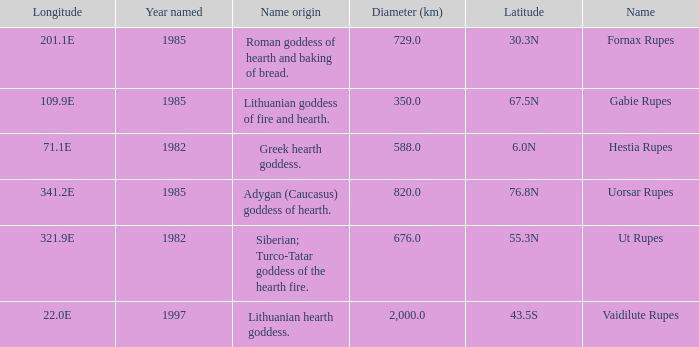At a latitude of 67.5n, what is the diameter? 350.0. 